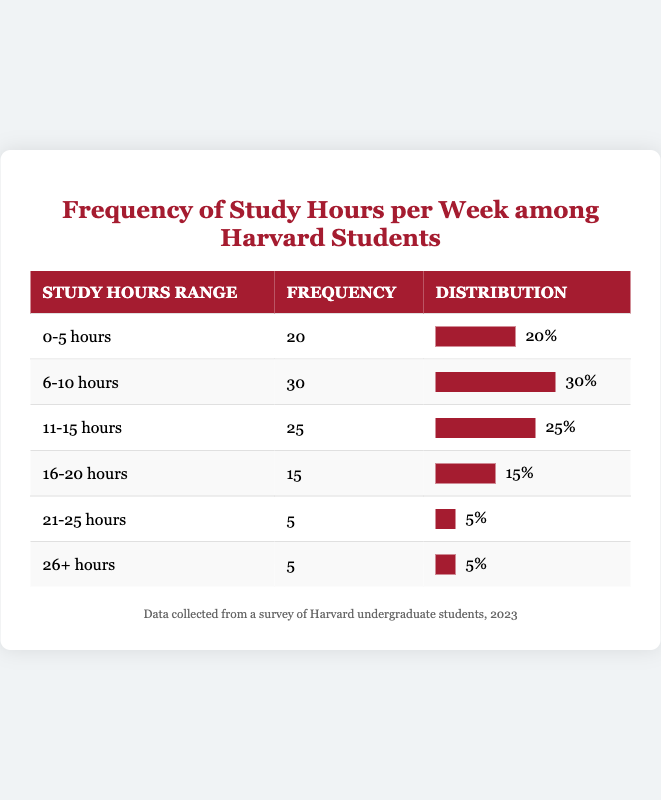What is the frequency of students studying 0-5 hours? The table indicates that the frequency of students studying within the 0-5 hours range is listed in the frequency column next to that range. It shows a frequency value of 20.
Answer: 20 What is the total frequency of students studying 16 hours or more? To find this, we need to sum the frequencies of the ranges 16-20 hours (15), 21-25 hours (5), and 26+ hours (5). The total frequency is \(15 + 5 + 5 = 25\).
Answer: 25 How many students study between 6-10 hours? The frequency of students studying between 6-10 hours can be directly found in the table, which shows a frequency value of 30.
Answer: 30 Is the frequency of students studying 21-25 hours greater than those studying 16-20 hours? From the table, the frequency for students studying 21-25 hours is 5, while for 16-20 hours it is 15. Since 5 is less than 15, the statement is false.
Answer: No What percentage of students study 11-15 hours? The frequency for students studying 11-15 hours is 25. To find the percentage, divide this by the total number of students (which is \(20 + 30 + 25 + 15 + 5 + 5 = 100\)) and multiply by 100: \((25/100) \times 100 = 25\)%.
Answer: 25% What is the difference in frequency between students studying 6-10 hours and those studying 16-20 hours? The frequency for students studying 6-10 hours is 30 and for 16-20 hours is 15. The difference is calculated as \(30 - 15 = 15\).
Answer: 15 What is the total frequency of students studying less than 11 hours? To find this, sum the frequencies of the ranges 0-5 hours (20), and 6-10 hours (30). Thus, the total frequency is \(20 + 30 = 50\).
Answer: 50 Is it true that there are more students studying between 11-15 hours than 21-25 hours? The frequency for 11-15 hours is 25 and for 21-25 hours is 5. Since 25 is greater than 5, the statement is true.
Answer: Yes What is the average number of study hours among the ranges given? First, calculate the midpoint of each range and then find the weighted average by multiplying each midpoint by its frequency, summing those, and dividing by total frequency. The midpoints are: (2.5, 8, 12, 18, 23, 26). So, calculate \( (2.5*20 + 8*30 + 12*25 + 18*15 + 23*5 + 26*5) / 100 = (50 + 240 + 300 + 270 + 115 + 130) / 100 = 1105 / 100 = 11.05\).
Answer: 11.05 